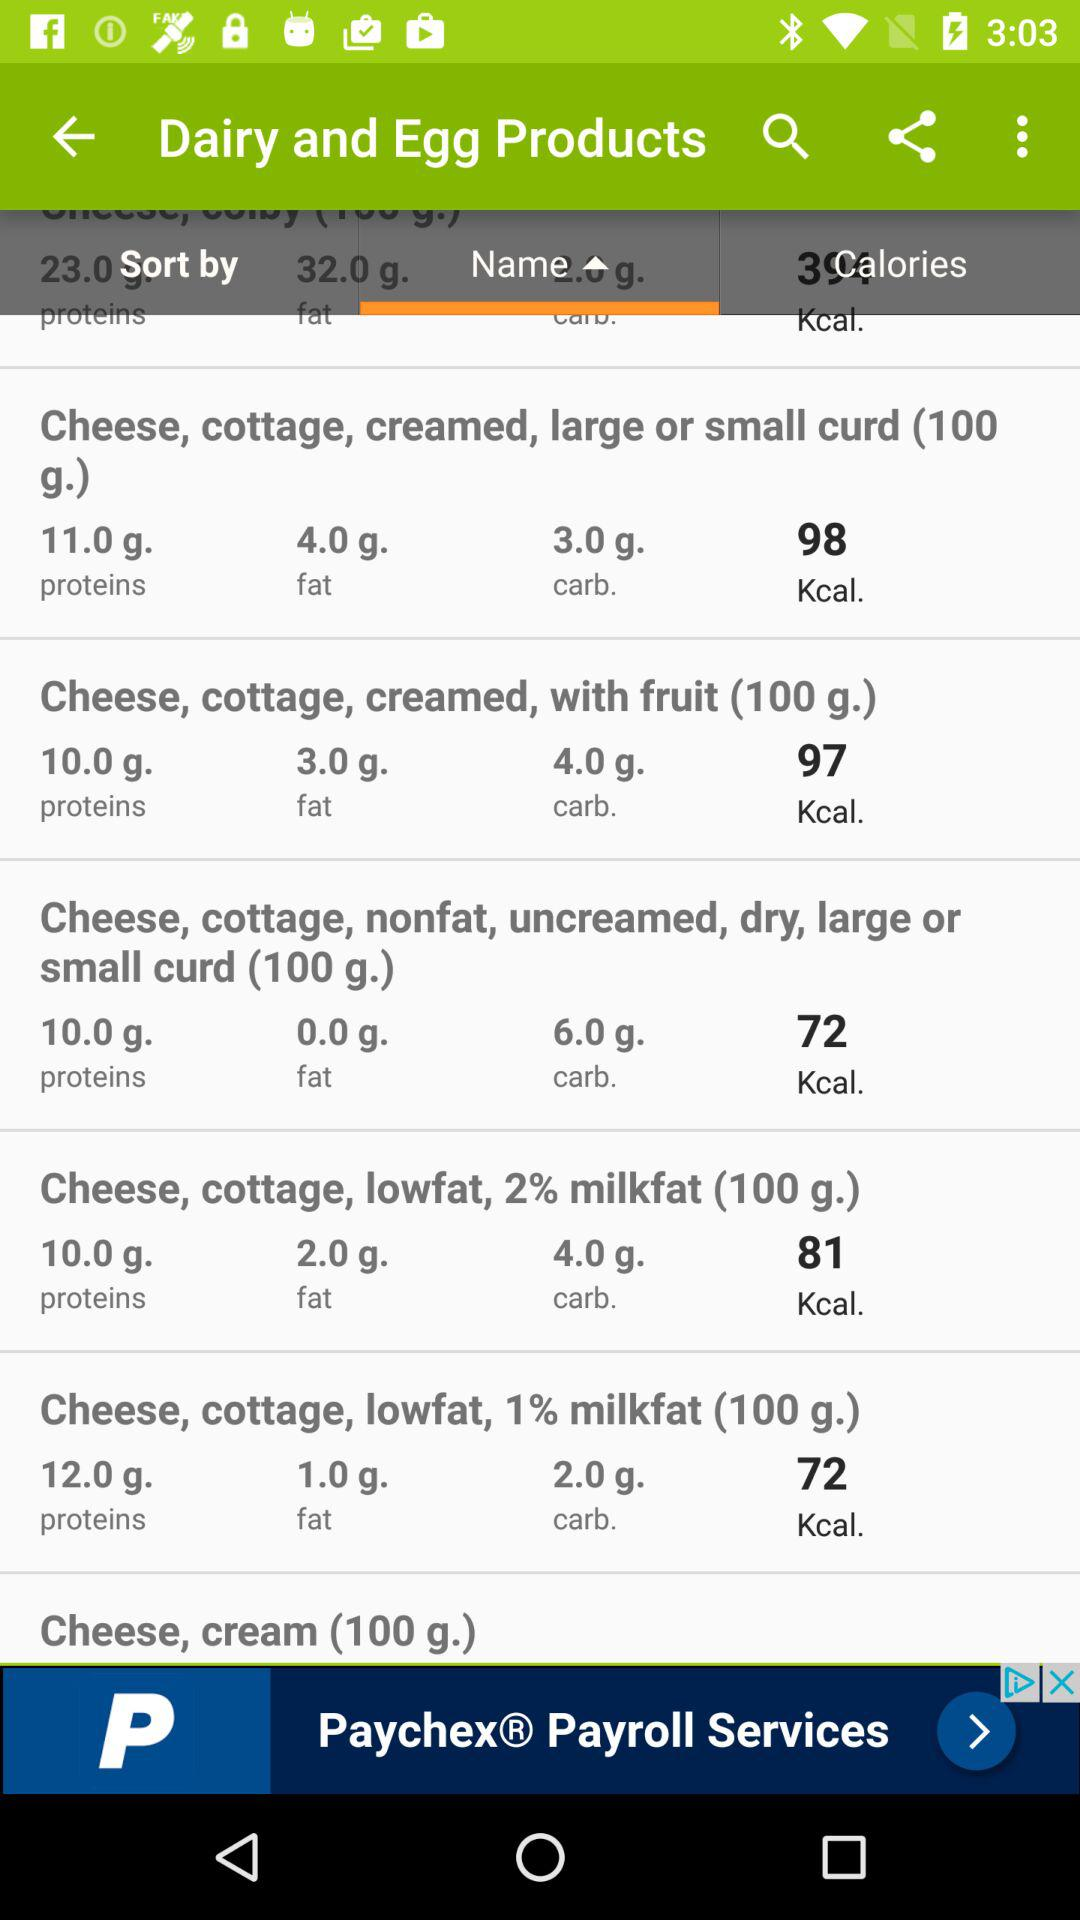What's the fat in "Cheese, cottage, creamed, large or small curd (100g.)"? The fat is 4.0 grams. 